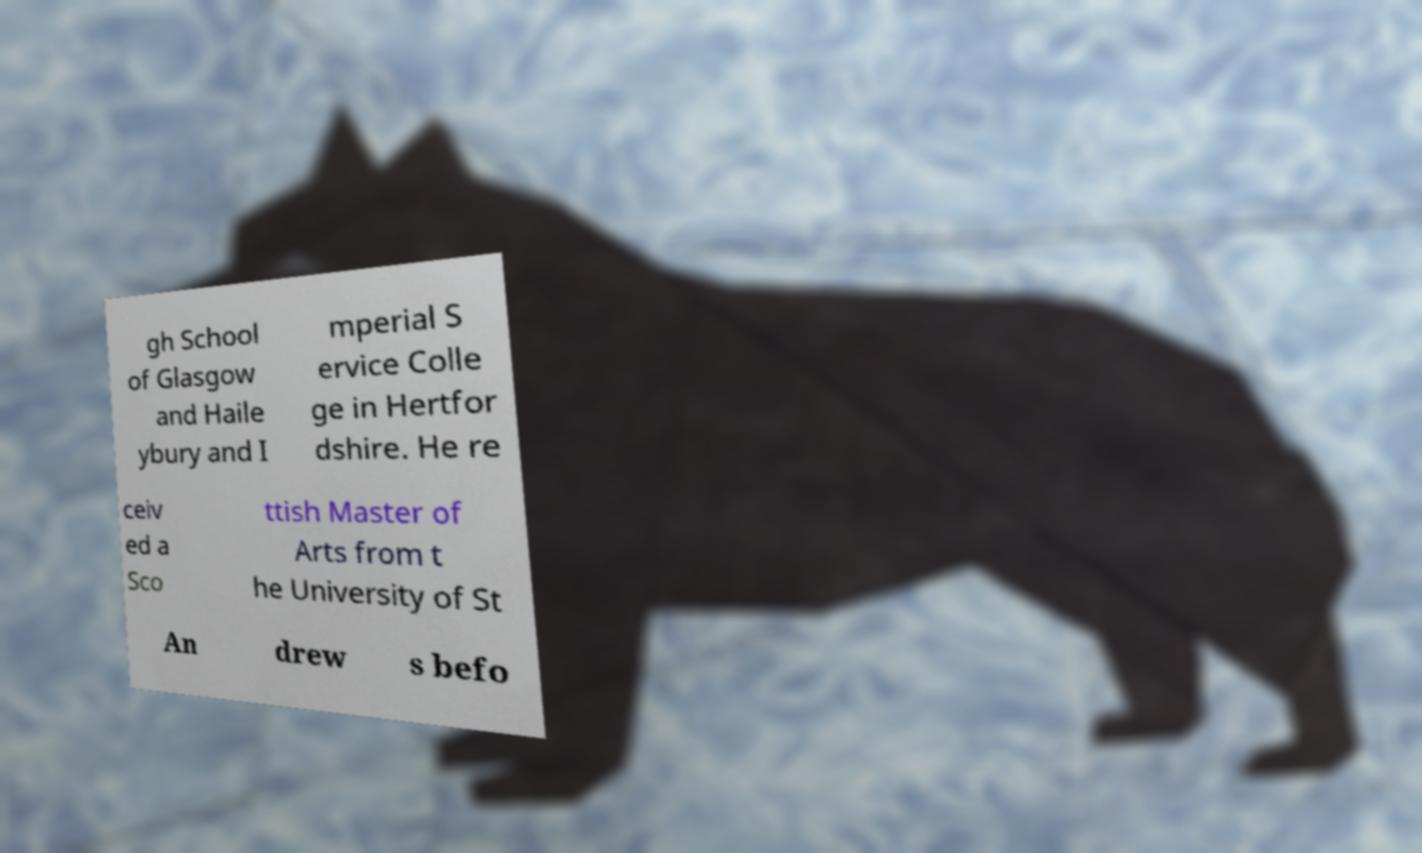Can you read and provide the text displayed in the image?This photo seems to have some interesting text. Can you extract and type it out for me? gh School of Glasgow and Haile ybury and I mperial S ervice Colle ge in Hertfor dshire. He re ceiv ed a Sco ttish Master of Arts from t he University of St An drew s befo 